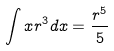Convert formula to latex. <formula><loc_0><loc_0><loc_500><loc_500>\int x r ^ { 3 } d x = \frac { r ^ { 5 } } { 5 }</formula> 